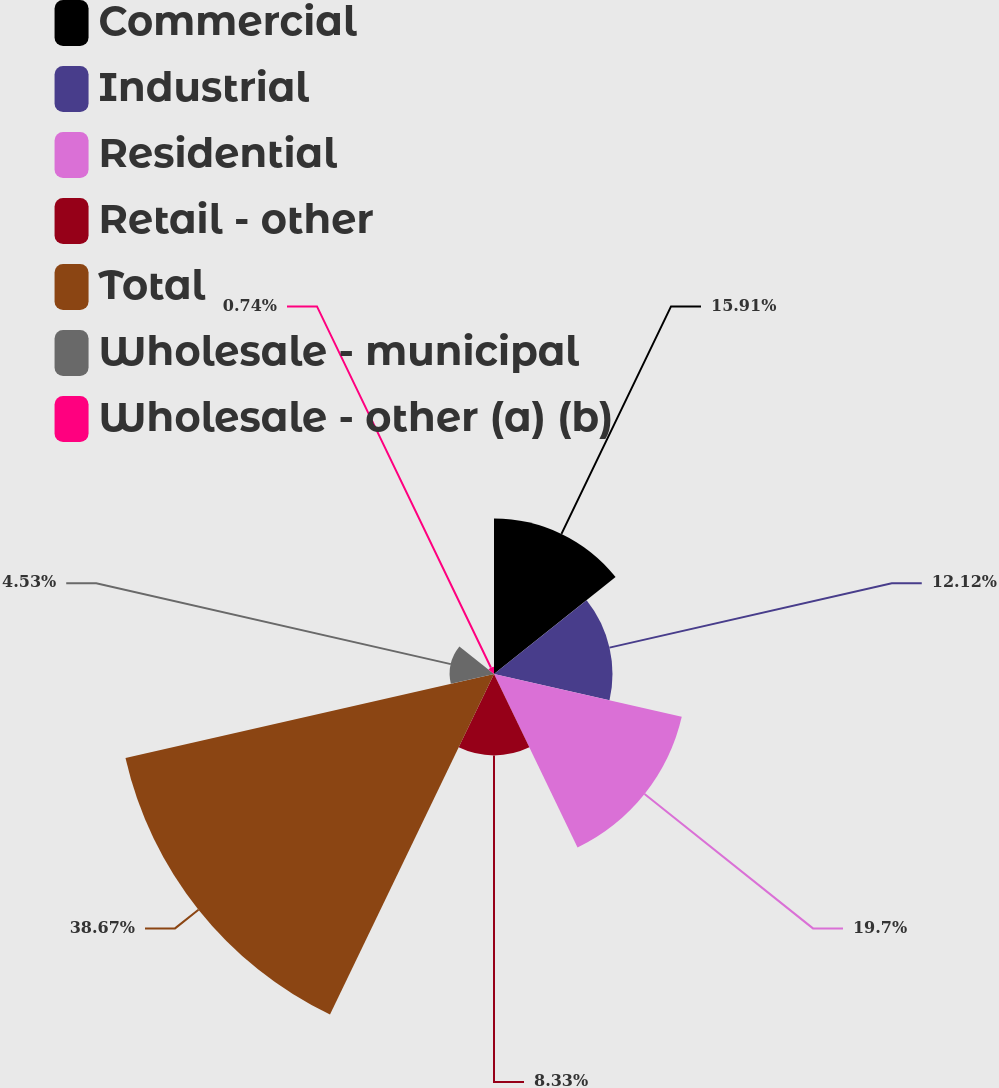Convert chart. <chart><loc_0><loc_0><loc_500><loc_500><pie_chart><fcel>Commercial<fcel>Industrial<fcel>Residential<fcel>Retail - other<fcel>Total<fcel>Wholesale - municipal<fcel>Wholesale - other (a) (b)<nl><fcel>15.91%<fcel>12.12%<fcel>19.7%<fcel>8.33%<fcel>38.67%<fcel>4.53%<fcel>0.74%<nl></chart> 